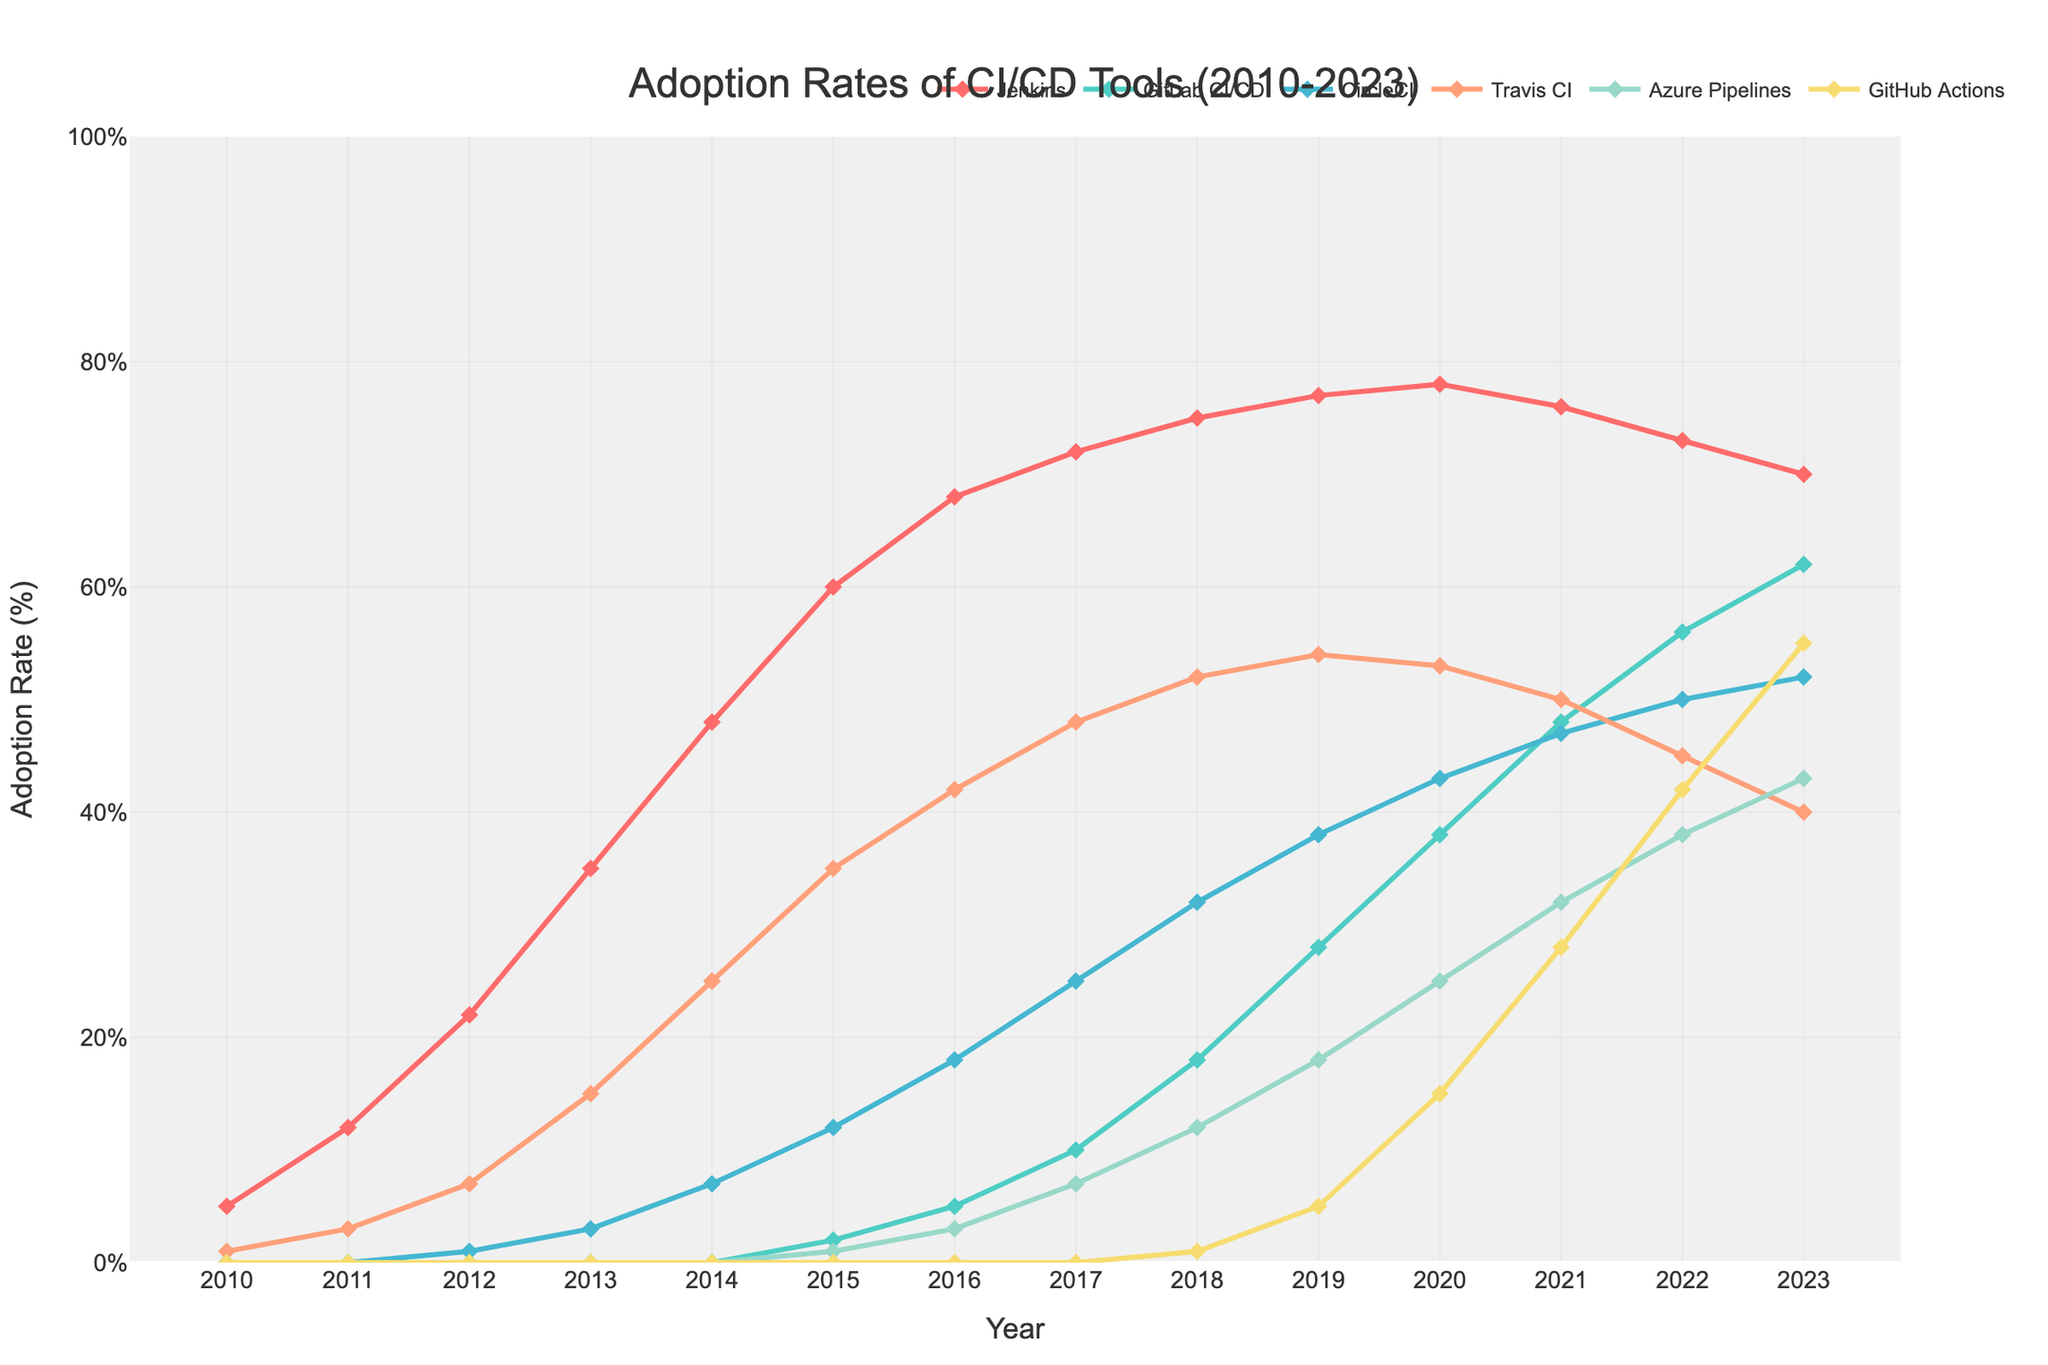What was the most popular CI/CD tool in 2023? The most popular CI/CD tool in 2023 is the one with the highest adoption rate. By looking at the lines in the chart, GitHub Actions has the highest adoption rate in 2023.
Answer: GitHub Actions How did the adoption rate of Jenkins change from 2010 to 2023? To determine how the adoption rate changed, we can look at the starting value in 2010 and the ending value in 2023 for Jenkins. In 2010, Jenkins had an adoption rate of 5%, and it increased to 70% in 2023.
Answer: Increased Between 2018 and 2023, which CI/CD tool showed the most significant increase in adoption rate? The most significant increase is calculated by the difference between the adoption rates in 2023 and 2018. GitLab CI/CD increased from 18% to 62%, a total increase of 44 percentage points, which is the largest among the tools.
Answer: GitLab CI/CD Which CI/CD tool saw a decline in adoption rate from 2019 to 2023? To find a decline, compare the adoption rates from 2019 to 2023 for each tool. Travis CI declined from 54% in 2019 to 40% in 2023.
Answer: Travis CI What is the difference in adoption rates between Jenkins and GitHub Actions in 2020? Jenkins had an adoption rate of 78% and GitHub Actions had 15% in 2020. The difference is 78% - 15% = 63%.
Answer: 63% In which year did Azure Pipelines first reach a double-digit adoption rate? We look for the first year where Azure Pipelines had an adoption rate of at least 10%. This occurred in 2018, where it had a 12% adoption rate.
Answer: 2018 Which two CI/CD tools had the closest adoption rates in 2023, and what was the difference between them? The closest adoption rates in 2023 can be found by comparing the absolute differences between adoption rates. Azure Pipelines and CircleCI were the closest with adoption rates of 43% and 52% respectively, giving a difference of 9 percentage points.
Answer: Azure Pipelines and CircleCI; 9% What is the average adoption rate of CircleCI over the period from 2010 to 2023? Sum the adoption rates of CircleCI from 2010 to 2023 and divide by the number of years. The rates are 0, 0, 1, 3, 7, 12, 18, 25, 32, 38, 43, 47, 50, 52 which add up to 328. There are 14 years, so the average is 328 / 14 ≈ 23.43%.
Answer: 23.43% Compare the adoption rates of Jenkins and GitLab CI/CD in 2015 and describe the trend you observe in subsequent years. In 2015, Jenkins was at 60% and GitLab CI/CD was at 2%. Over the subsequent years, Jenkins showed a slight increase and then a gradual decline, whereas GitLab CI/CD showed a substantial increase annually.
Answer: Jenkins initially increased, then declined; GitLab CI/CD continuously increased 